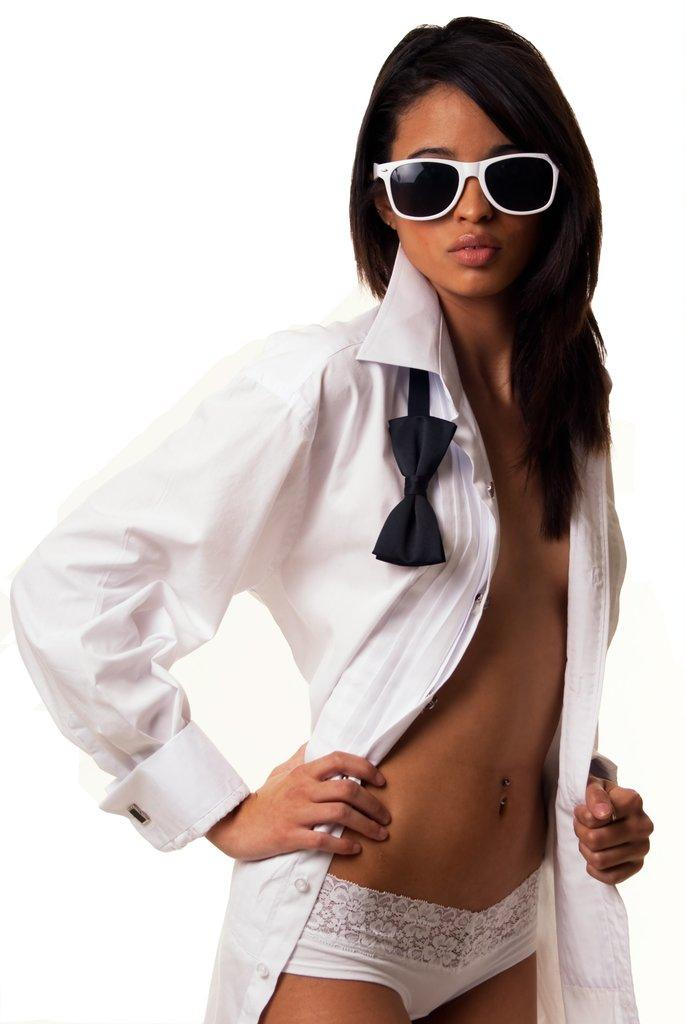Who is the main subject in the image? There is a lady in the image. What is the lady wearing on her upper body? The lady is wearing a white shirt. What type of eyewear is the lady wearing? The lady is wearing sunglasses. What is the color of the background in the image? The background of the image is white in color. What type of health issues does the lady in the image have? There is no information about the lady's health in the image, so we cannot determine any health issues. Can you tell me how many acres of land are visible in the image? There is no land visible in the image; it features a lady in the foreground and a white background. 